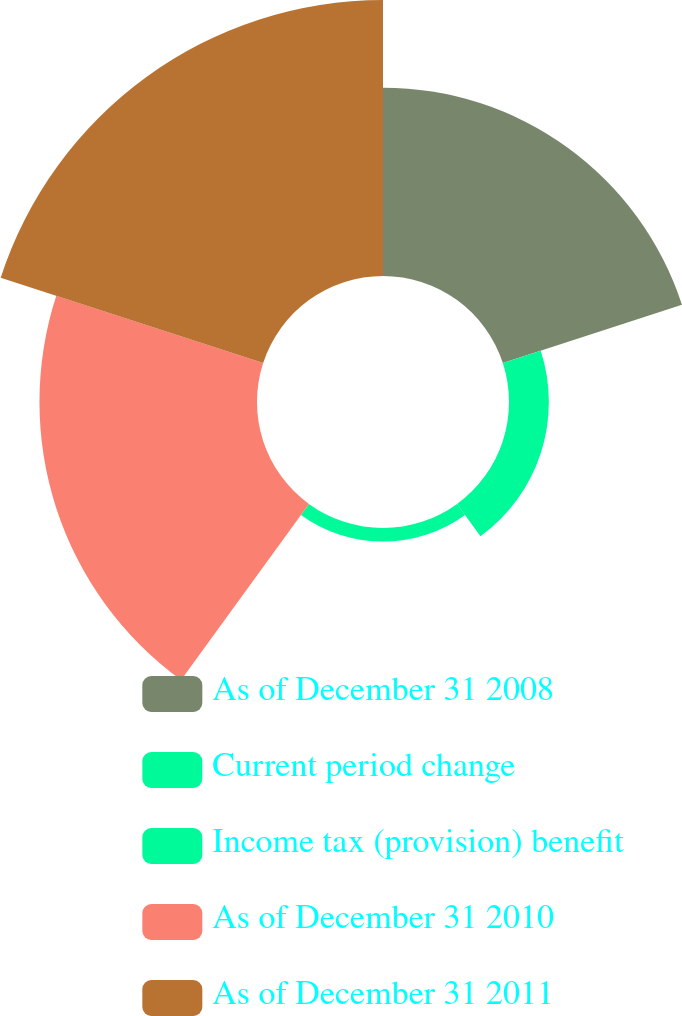Convert chart to OTSL. <chart><loc_0><loc_0><loc_500><loc_500><pie_chart><fcel>As of December 31 2008<fcel>Current period change<fcel>Income tax (provision) benefit<fcel>As of December 31 2010<fcel>As of December 31 2011<nl><fcel>25.61%<fcel>5.42%<fcel>1.85%<fcel>29.58%<fcel>37.53%<nl></chart> 